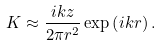Convert formula to latex. <formula><loc_0><loc_0><loc_500><loc_500>K \approx \frac { i k z } { 2 \pi r ^ { 2 } } \exp \left ( i k r \right ) .</formula> 